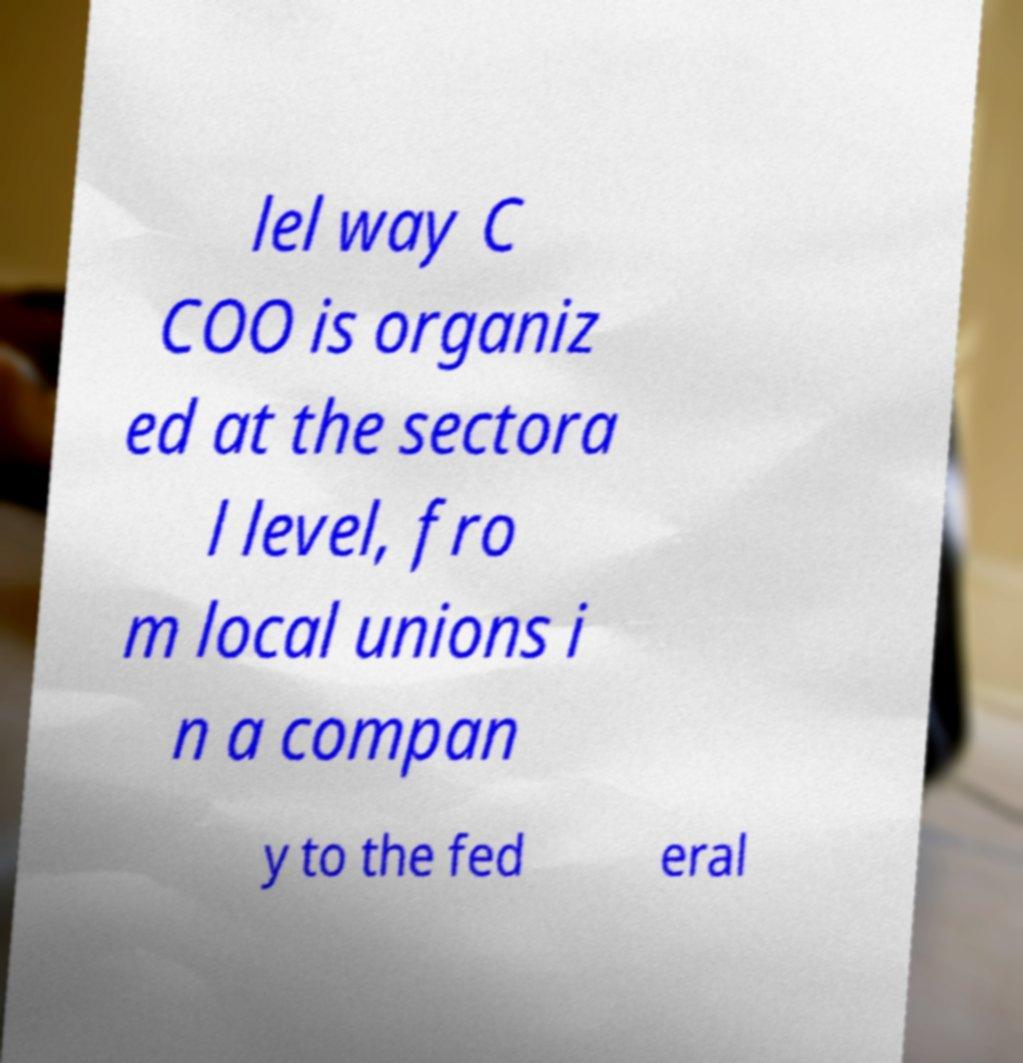For documentation purposes, I need the text within this image transcribed. Could you provide that? lel way C COO is organiz ed at the sectora l level, fro m local unions i n a compan y to the fed eral 